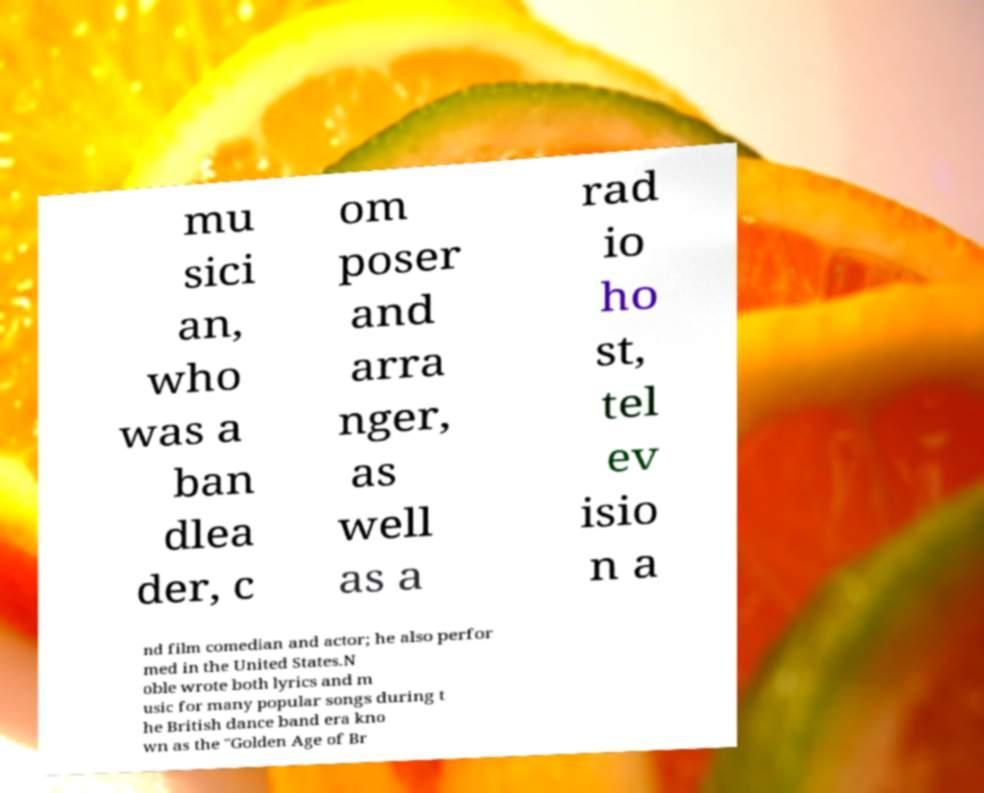Could you assist in decoding the text presented in this image and type it out clearly? mu sici an, who was a ban dlea der, c om poser and arra nger, as well as a rad io ho st, tel ev isio n a nd film comedian and actor; he also perfor med in the United States.N oble wrote both lyrics and m usic for many popular songs during t he British dance band era kno wn as the "Golden Age of Br 